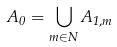<formula> <loc_0><loc_0><loc_500><loc_500>A _ { 0 } = \bigcup _ { m \in N } A _ { 1 , m }</formula> 